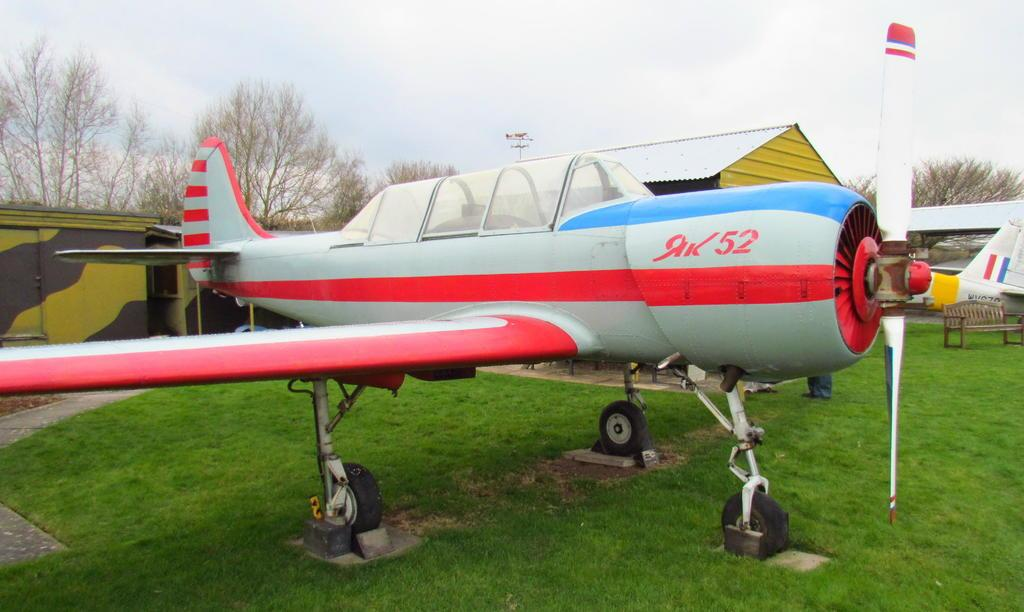Provide a one-sentence caption for the provided image. A striped red, white and blue small airplane sets on a grassy field, the label AK52 is on the side next to the propeller. 